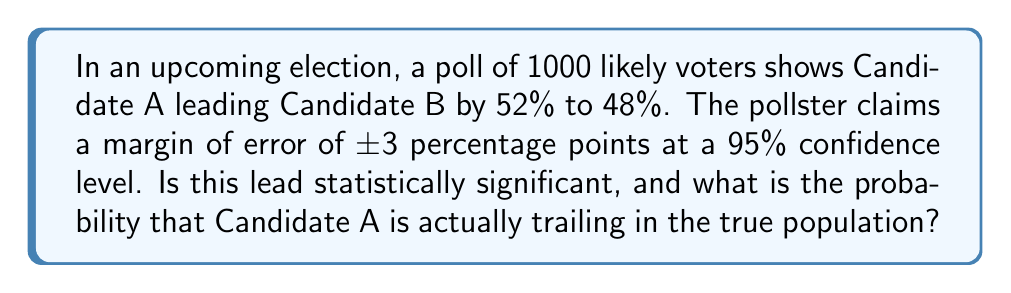Help me with this question. To determine statistical significance and calculate the probability that Candidate A is trailing, we'll follow these steps:

1. Calculate the standard error of the difference between proportions:
   $$SE = \sqrt{\frac{p(1-p)}{n_1} + \frac{p(1-p)}{n_2}}$$
   where $p = 0.52$ (proportion for Candidate A), $n_1 = n_2 = 1000$
   $$SE = \sqrt{\frac{0.52(0.48)}{1000} + \frac{0.52(0.48)}{1000}} = 0.0223$$

2. Calculate the z-score for the difference:
   $$z = \frac{\text{Observed Difference}}{\text{Standard Error}} = \frac{0.52 - 0.48}{0.0223} = 1.79$$

3. Determine statistical significance:
   At 95% confidence level, the critical z-value is 1.96. Since 1.79 < 1.96, the lead is not statistically significant at this level.

4. Calculate the probability that Candidate A is trailing:
   This is equivalent to finding the area under the normal curve to the left of z = 0 (where the difference is 0).
   $$P(\text{A trailing}) = P(z < -1.79) = 0.0367$$

   We can find this using a standard normal distribution table or calculator function.
Answer: Not statistically significant; 3.67% probability Candidate A is trailing 